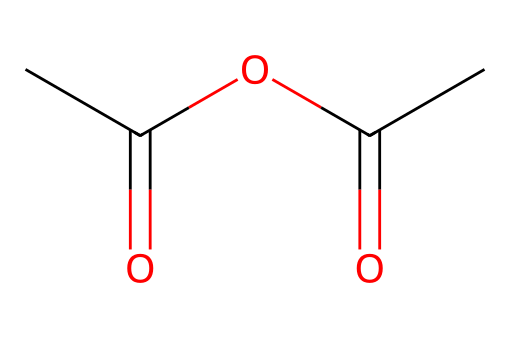What is the name of the chemical represented by this SMILES? The given SMILES representation CC(=O)OC(=O)C corresponds to acetic anhydride, which is a derivative of acetic acid.
Answer: acetic anhydride How many carbon atoms are in this molecule? By examining the SMILES, we see "CC(=O)" indicates two carbon atoms, "C(=O)" adds one more carbon, and the singular "C" at the end adds another. In total, there are four carbon atoms.
Answer: four What type of bonds are present in this chemical structure? Analyzing the SMILES, we find that the '=' indicates double bonds (specifically C=O), while the connections between the carbon atoms and to the oxygen atoms represent single bonds. Therefore, both single and double bonds are present.
Answer: single and double bonds How many oxygen atoms are present in acetic anhydride? Looking closely at the SMILES, we see two "O" for the carbonyl groups and one more due to the ether linkage, which sums up to three oxygen atoms in total.
Answer: three What functional groups are found in acetic anhydride? The molecule contains carbonyl functional groups (C=O) from the anhydride and an ether (C-O-C) component. These define the compound as an acid anhydride.
Answer: carbonyl and ether Is acetic anhydride an acid or a base? Analyzing the properties of acetic anhydride, it is derived from acetic acid and lacks a proton donor, characterizing it as acidic rather than basic.
Answer: acid What is the chemical classification of acetic anhydride? Acetic anhydride is classified as an acid anhydride because it is formed from the removal of water from two acetic acid molecules.
Answer: acid anhydride 